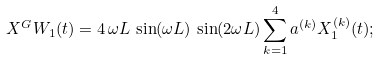<formula> <loc_0><loc_0><loc_500><loc_500>X ^ { G } W _ { 1 } ( t ) = 4 \, \omega L \, \sin ( \omega L ) \, \sin ( 2 \omega L ) \sum _ { k = 1 } ^ { 4 } a ^ { ( k ) } X ^ { ( k ) } _ { 1 } ( t ) ;</formula> 